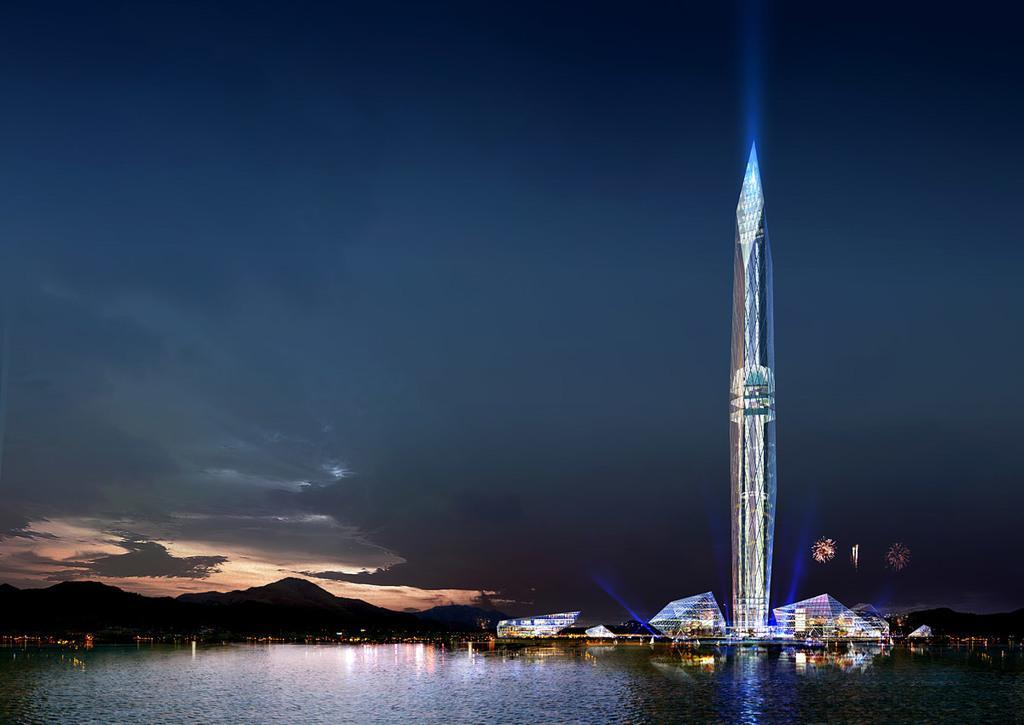In one or two sentences, can you explain what this image depicts? This image consists of water. In the front, we can see buildings and a skyscraper. In the background, there are mountains. At the top, there are clouds in the sky. 